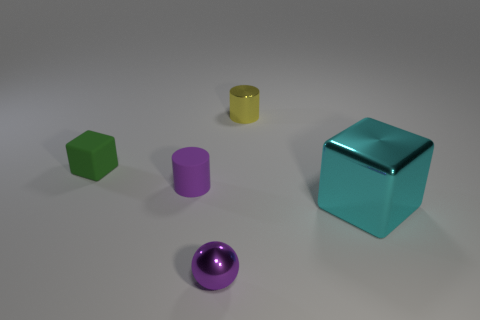Does the ball have the same size as the green thing? Upon closer inspection, the ball appears to be slightly smaller than the green cube when comparing their dimensions. 